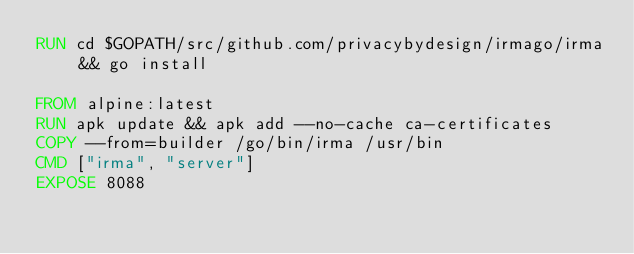<code> <loc_0><loc_0><loc_500><loc_500><_Dockerfile_>RUN cd $GOPATH/src/github.com/privacybydesign/irmago/irma && go install

FROM alpine:latest
RUN apk update && apk add --no-cache ca-certificates
COPY --from=builder /go/bin/irma /usr/bin
CMD ["irma", "server"]
EXPOSE 8088</code> 